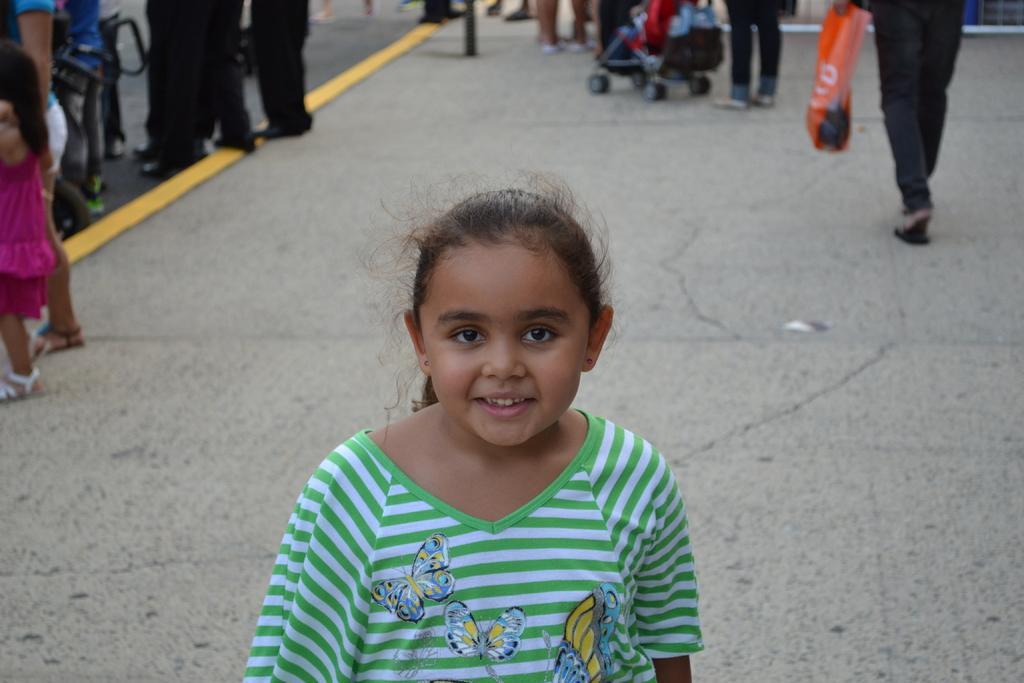In one or two sentences, can you explain what this image depicts? In the image we can see a girl standing wearing clothes and ear studs, and the girl is smiling. This is a footpath and yellow lines on it. There are even many people standing and some of them are walking, this is a plastic bag. 